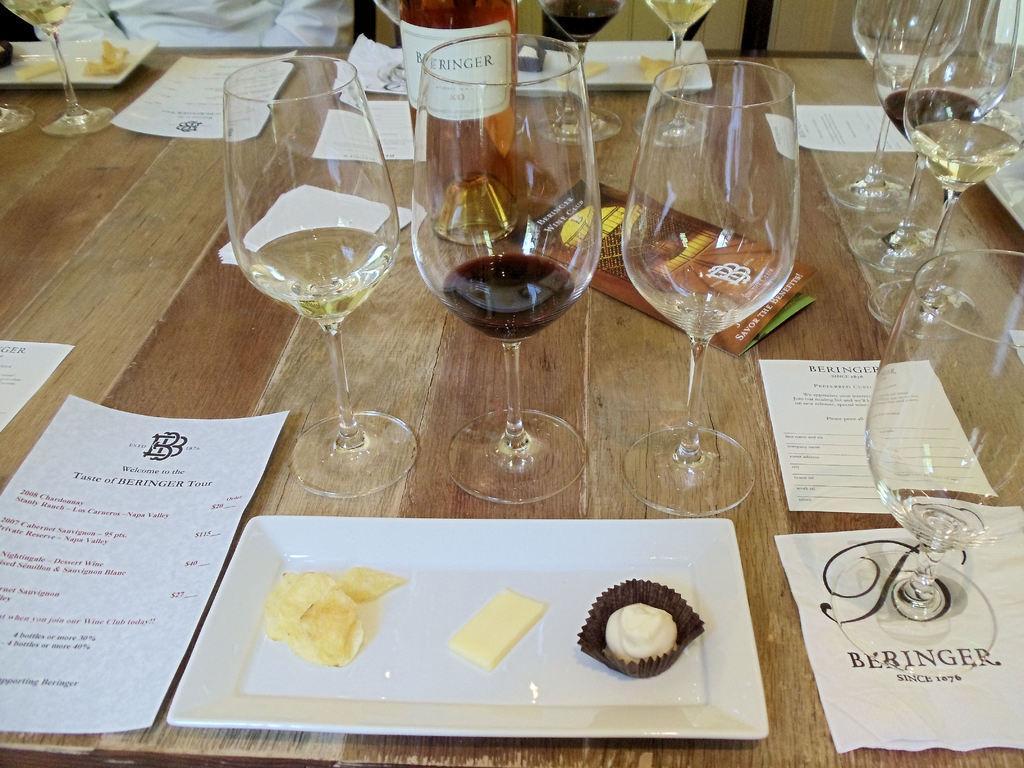Can you describe this image briefly? In the middle of the image there is a table, On the table there are some glasses and there is a bottle. Bottom of the image there is a plate, On the plate there is some food items. Bottom left side of the image there is a paper. Top left side of the image there is a man. 